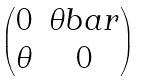<formula> <loc_0><loc_0><loc_500><loc_500>\begin{pmatrix} 0 & \theta b a r \\ \theta & 0 \end{pmatrix}</formula> 